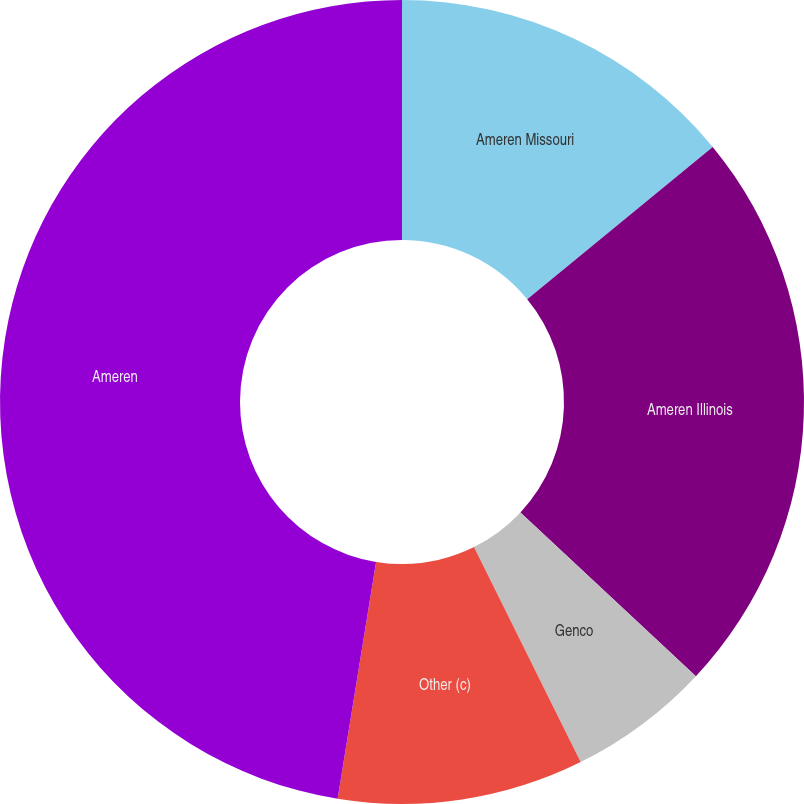Convert chart. <chart><loc_0><loc_0><loc_500><loc_500><pie_chart><fcel>Ameren Missouri<fcel>Ameren Illinois<fcel>Genco<fcel>Other (c)<fcel>Ameren<nl><fcel>14.06%<fcel>22.89%<fcel>5.72%<fcel>9.89%<fcel>47.44%<nl></chart> 